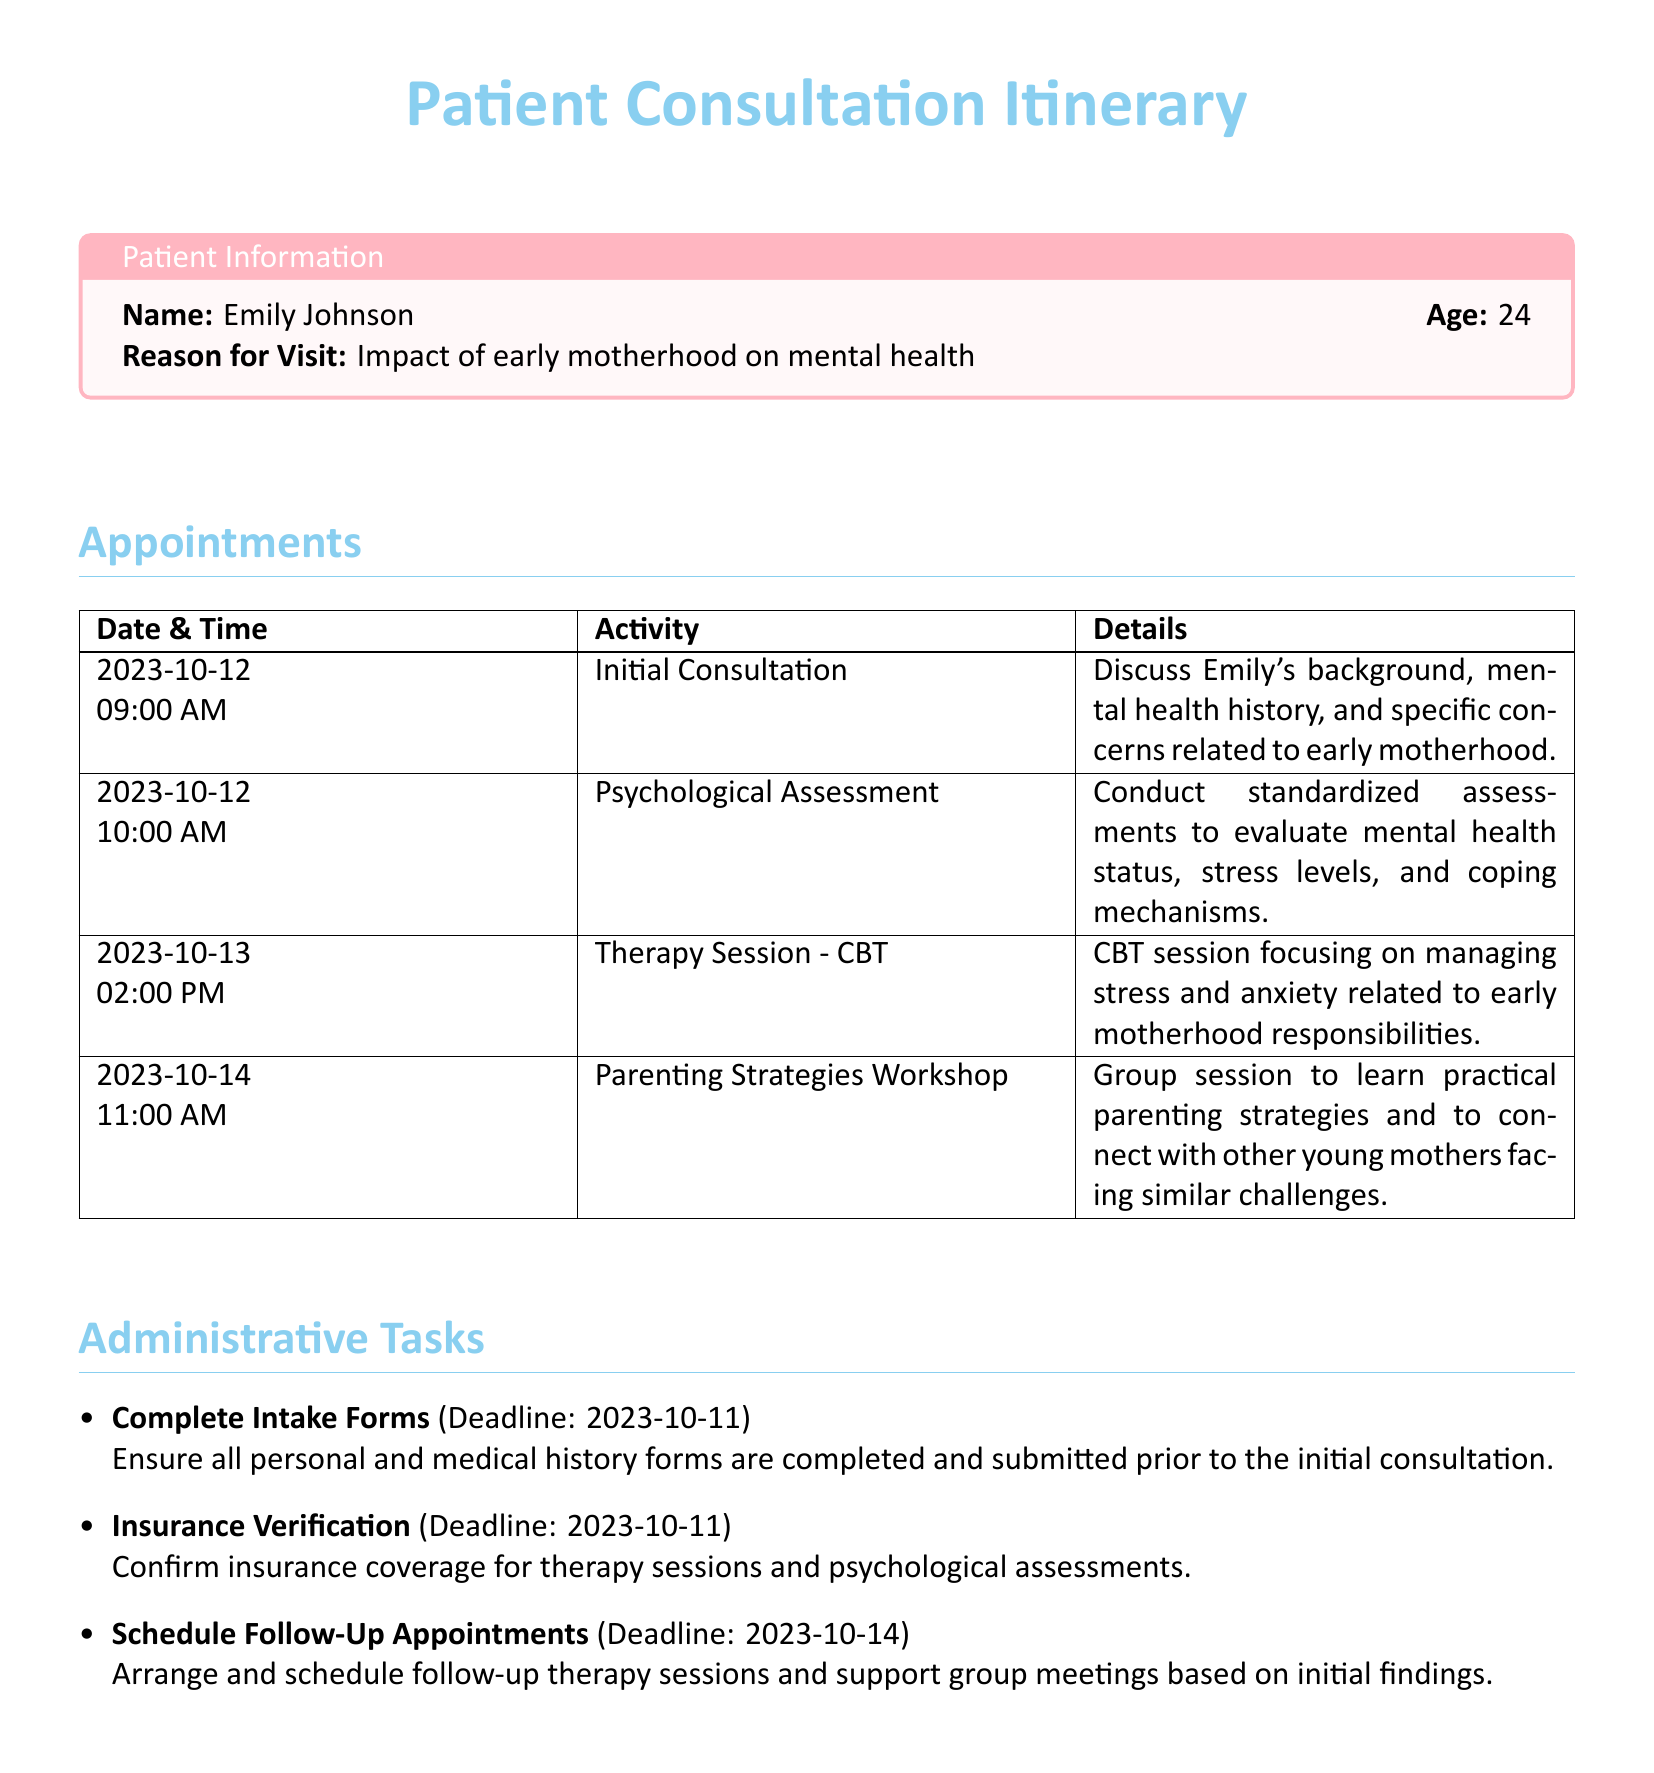What is the name of the patient? The patient's name is mentioned at the beginning of the document under Patient Information.
Answer: Emily Johnson What is the reason for the visit? The reason for the visit is specified in the Patient Information section.
Answer: Impact of early motherhood on mental health When is the initial consultation scheduled? The date and time of the initial consultation are found in the Appointments table.
Answer: 2023-10-12 09:00 AM What type of therapy session is scheduled on 2023-10-13? The type of therapy session is mentioned in the Appointments section for the specified date.
Answer: CBT What is the deadline for completing intake forms? The deadline for completing intake forms is listed in the Administrative Tasks section.
Answer: 2023-10-11 How many appointments are listed in the itinerary? The total number of appointments is counted from the Appointments table.
Answer: Four What is the activity scheduled for 2023-10-14 at 11:00 AM? The specific activity for that date and time is found in the Appointments section.
Answer: Parenting Strategies Workshop What is required to be done for insurance verification? The requirement for insurance verification can be found in the Administrative Tasks section.
Answer: Confirm insurance coverage What is the purpose of the psychological assessment? The purpose is mentioned in the details of the corresponding appointment.
Answer: Evaluate mental health status, stress levels, and coping mechanisms 